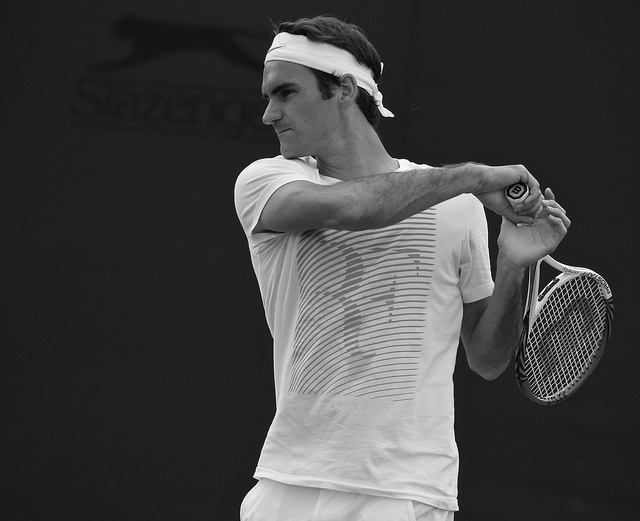Describe the objects in this image and their specific colors. I can see people in black, darkgray, gray, and lightgray tones and tennis racket in black, gray, darkgray, and lightgray tones in this image. 